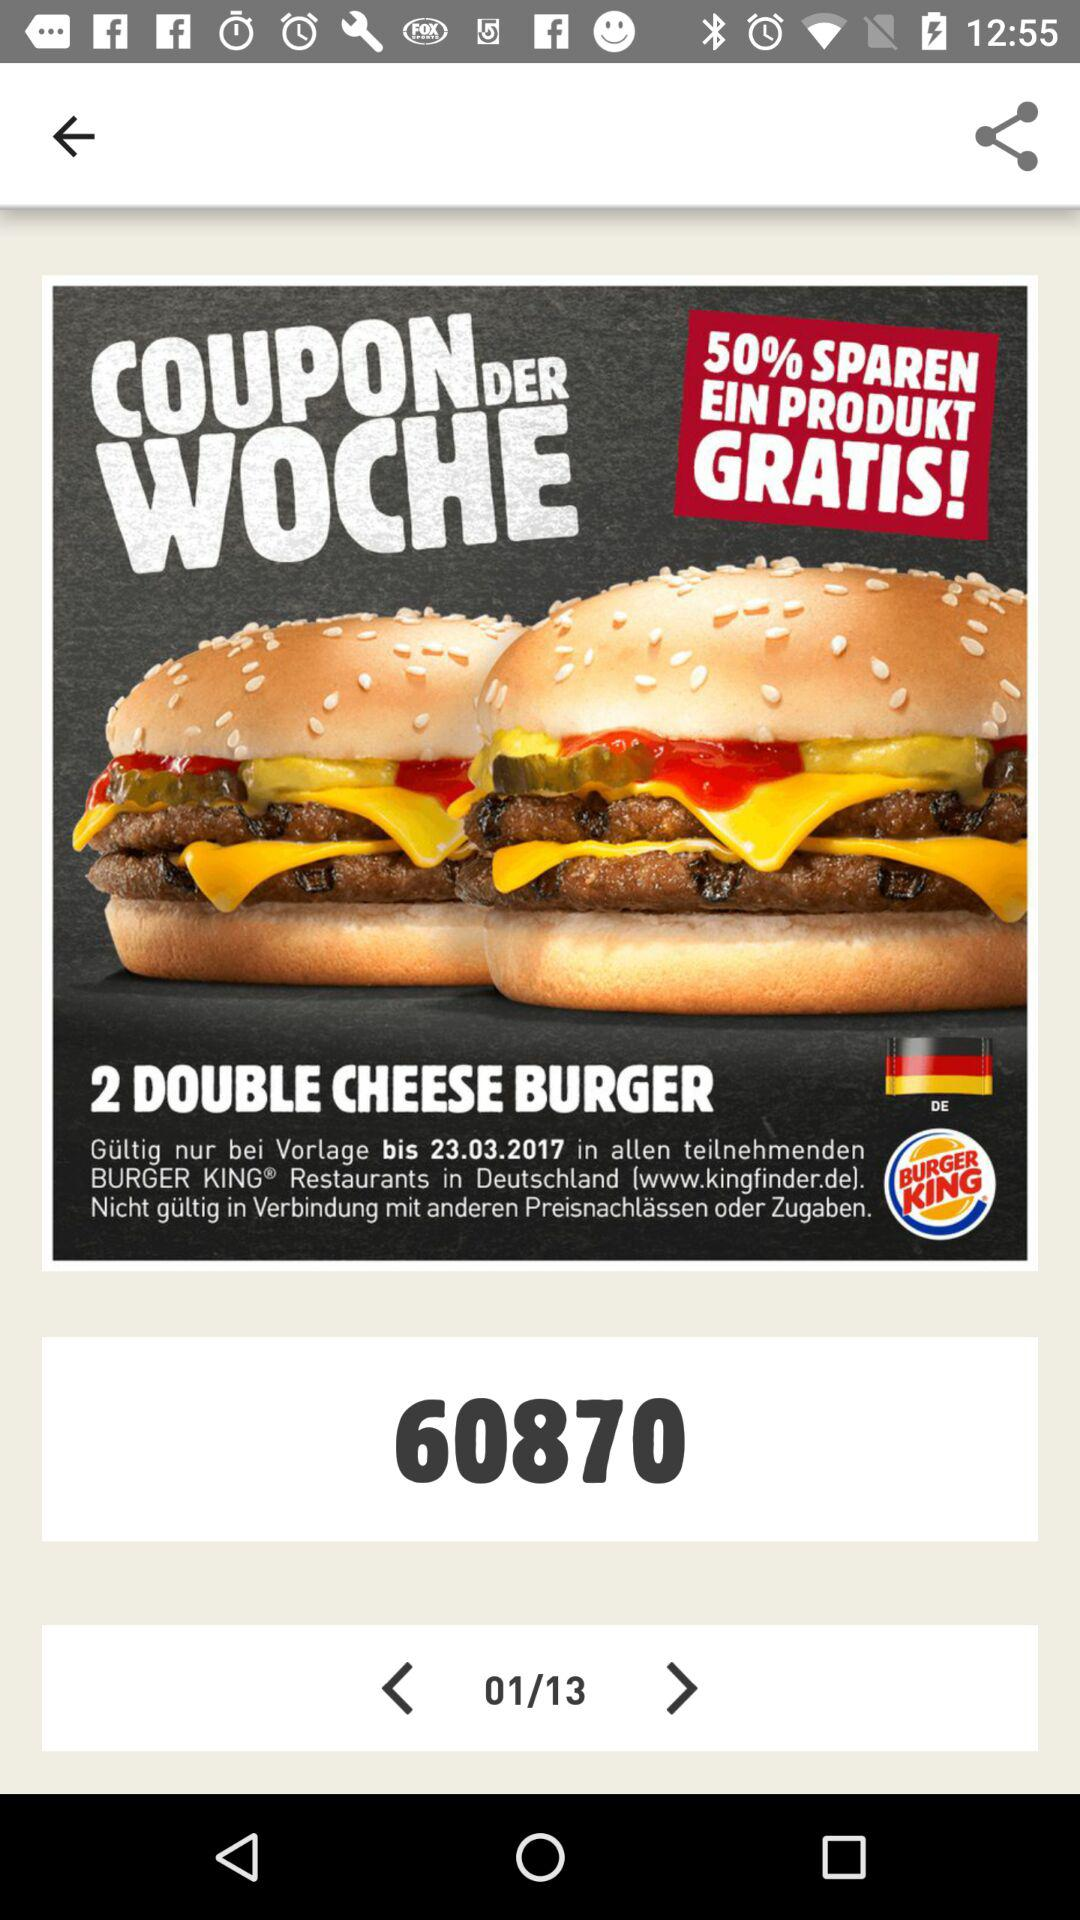On which page are we right now? Right now, you are on page 1. 